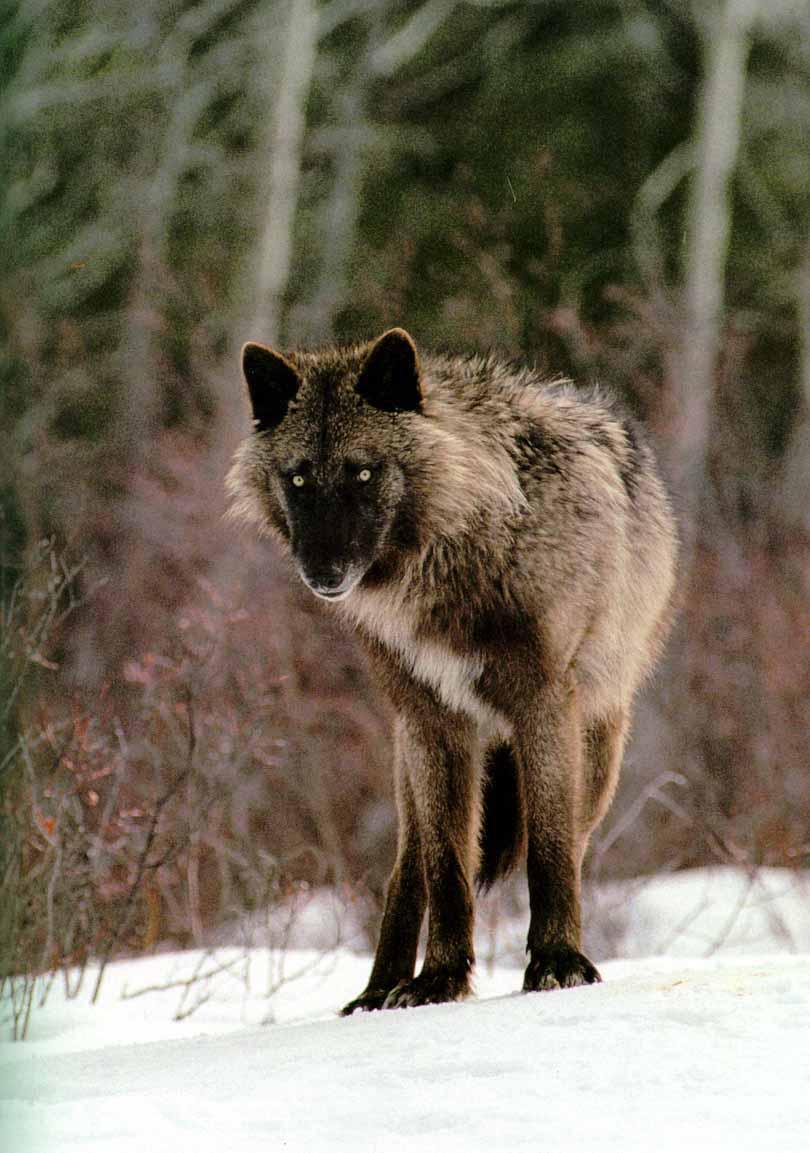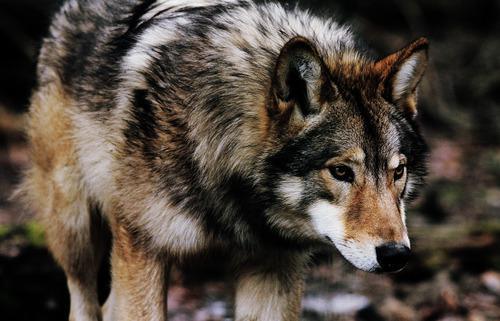The first image is the image on the left, the second image is the image on the right. Given the left and right images, does the statement "One wolf is facing to the right." hold true? Answer yes or no. Yes. 